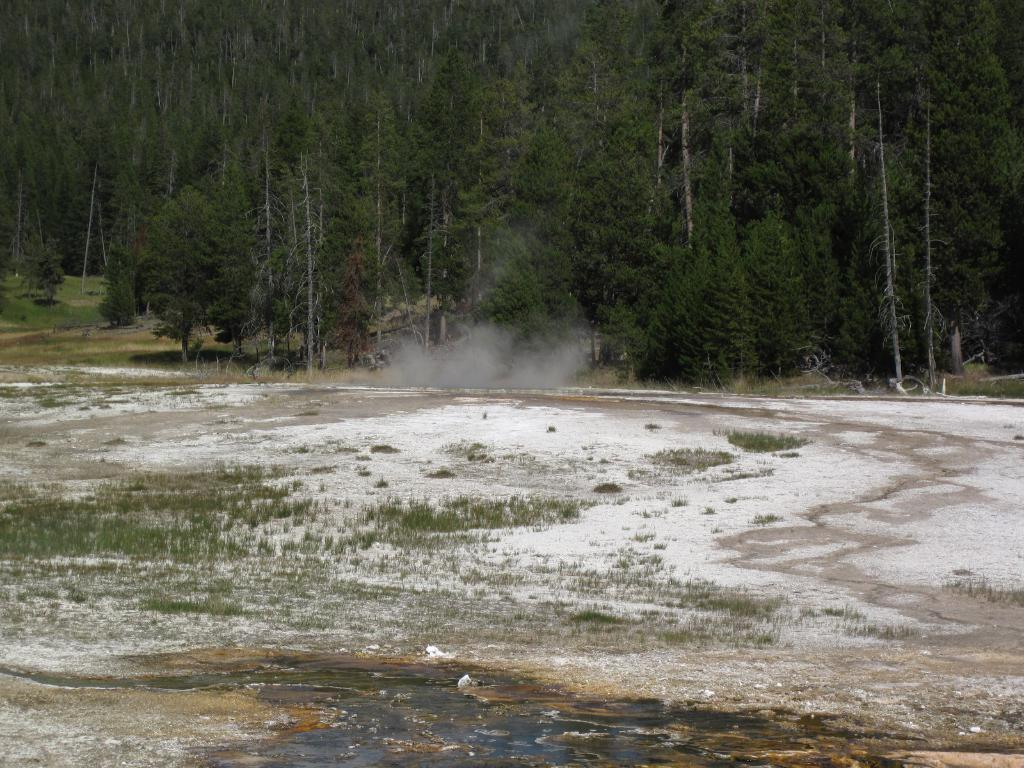What is visible in the foreground of the picture? In the foreground of the picture, there is grass, soil, and smoke. What can be seen in the background of the picture? In the background of the picture, there are trees, plants, and grass. What is the weather like in the image? The weather is sunny in the image. Can you hear someone coughing in the image? There is no audible information in the image, so it is not possible to determine if someone is coughing. Is there a cart visible in the image? There is no cart present in the image. 